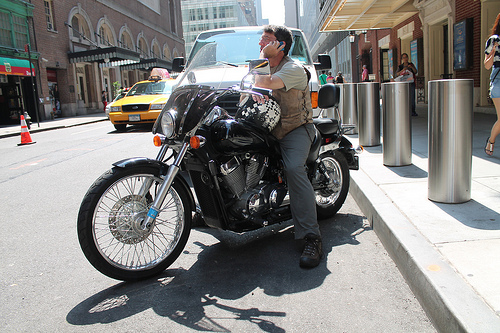Can you describe any safety equipment the person might be using while on the motorcycle? The person is wearing a white full-face helmet, which provides protection, and sunglasses that may protect his eyes from the sun and wind. 